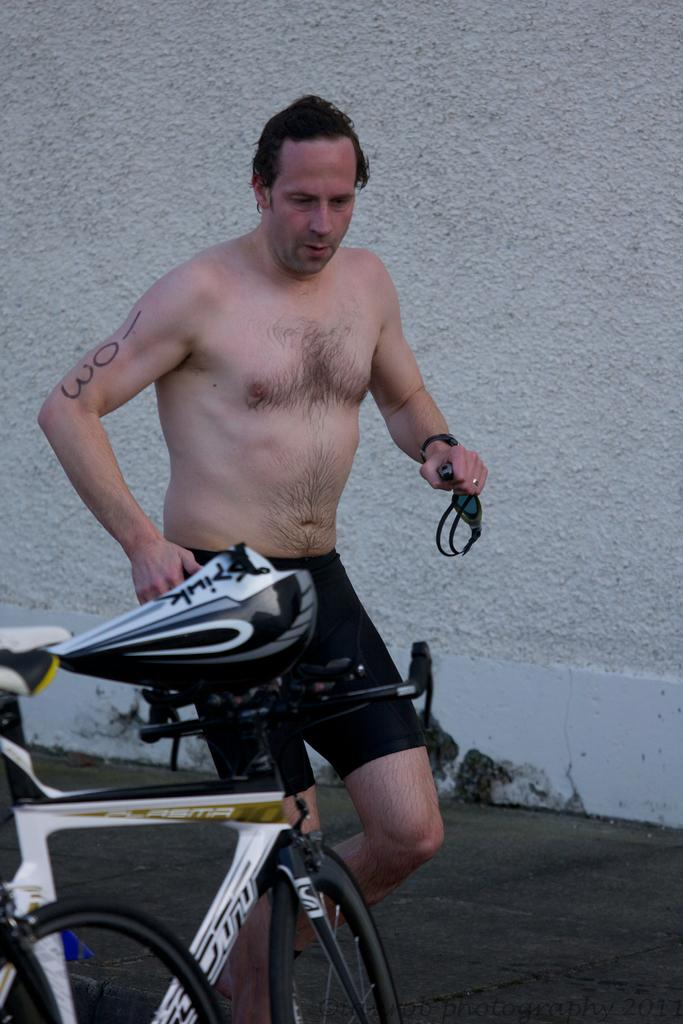Who or what is present in the image? There is a person in the image. What objects are associated with the person in the image? There are bicycles in the image. What can be seen in the background of the image? There is a wall in the background of the image. What type of sofa can be seen near the edge of the image? There is no sofa present in the image. 